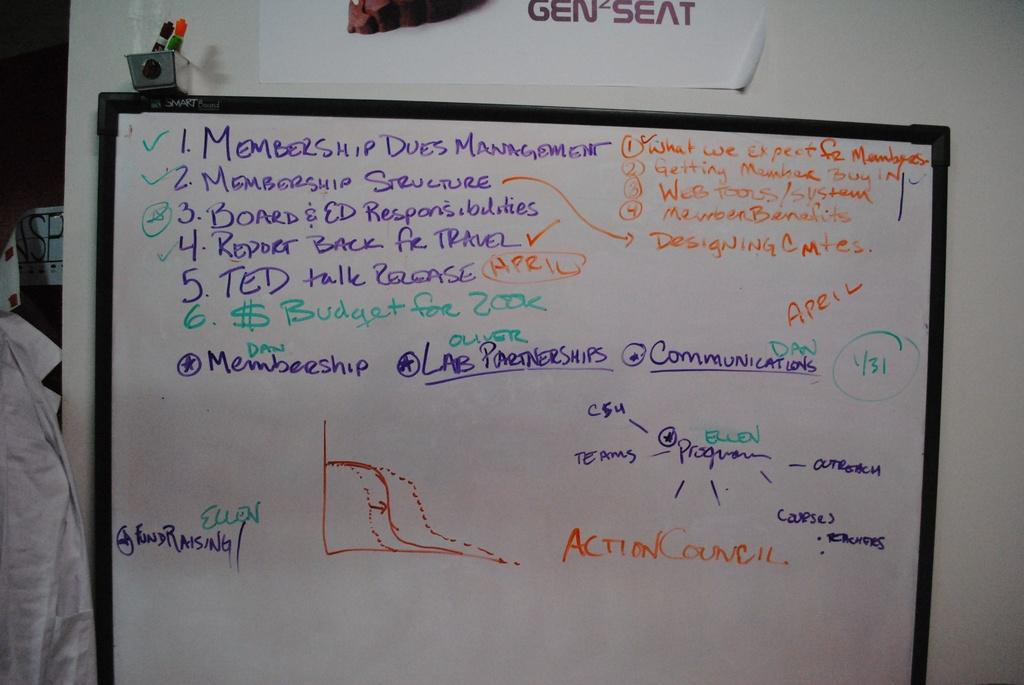<image>
Present a compact description of the photo's key features. A person has written about membership dues management on the white board. 